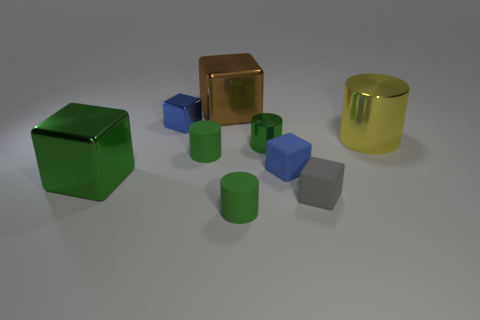What is the material of the big object that is to the right of the big green metallic cube and in front of the brown metallic cube?
Provide a succinct answer. Metal. What material is the green object that is the same shape as the brown object?
Your answer should be very brief. Metal. How many small blue shiny things have the same shape as the brown thing?
Provide a short and direct response. 1. Is the material of the big green object the same as the big block to the right of the green metallic cube?
Ensure brevity in your answer.  Yes. Are there more small green metal cylinders that are right of the tiny shiny cylinder than big red metallic objects?
Give a very brief answer. No. There is a tiny rubber thing that is the same color as the small metal cube; what shape is it?
Your answer should be very brief. Cube. Is there a large cube that has the same material as the large cylinder?
Give a very brief answer. Yes. Does the large cylinder that is on the right side of the brown block have the same material as the blue cube that is behind the tiny metal cylinder?
Provide a succinct answer. Yes. Are there an equal number of green metallic objects to the right of the tiny shiny cylinder and blocks to the right of the tiny gray rubber thing?
Your answer should be very brief. Yes. What color is the cylinder that is the same size as the brown metal block?
Provide a short and direct response. Yellow. 